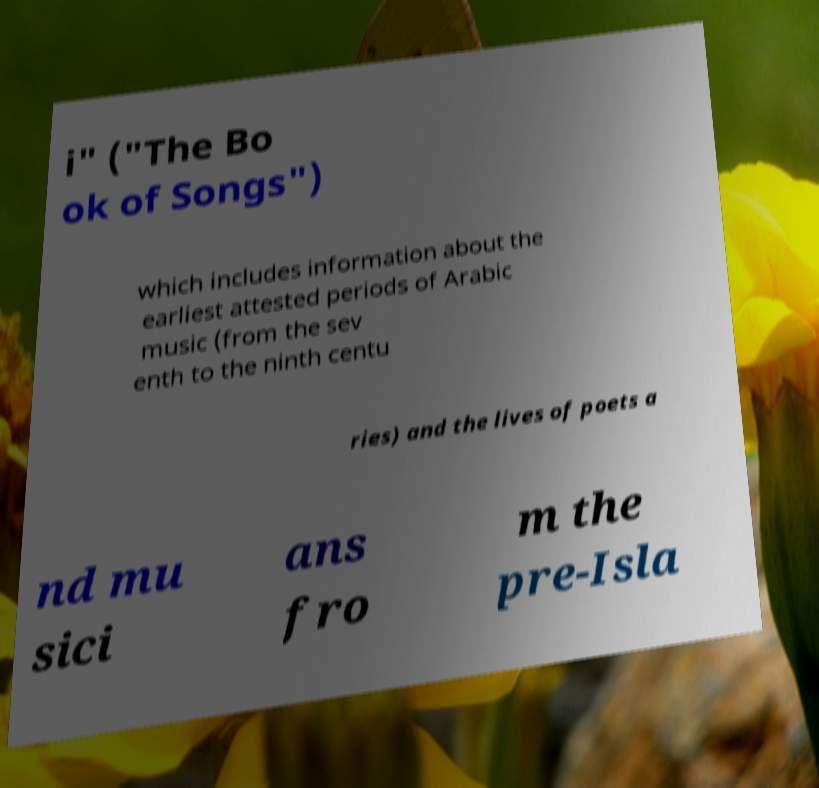Could you assist in decoding the text presented in this image and type it out clearly? i" ("The Bo ok of Songs") which includes information about the earliest attested periods of Arabic music (from the sev enth to the ninth centu ries) and the lives of poets a nd mu sici ans fro m the pre-Isla 